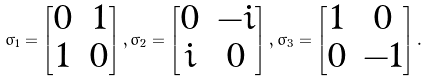<formula> <loc_0><loc_0><loc_500><loc_500>\sigma _ { 1 } = \left [ \begin{matrix} 0 & 1 \\ 1 & 0 \end{matrix} \right ] , \sigma _ { 2 } = \left [ \begin{matrix} 0 & - i \\ i & 0 \end{matrix} \right ] , \sigma _ { 3 } = \left [ \begin{matrix} 1 & 0 \\ 0 & - 1 \end{matrix} \right ] .</formula> 